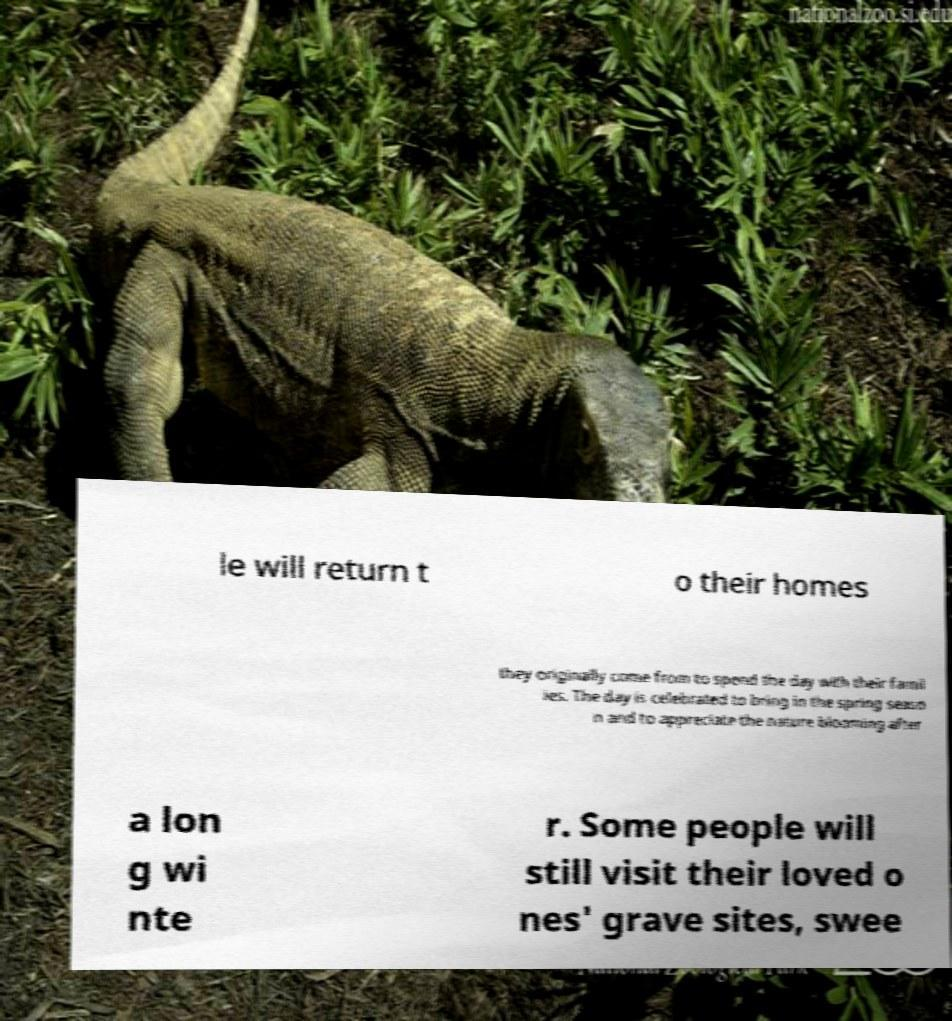Please read and relay the text visible in this image. What does it say? le will return t o their homes they originally come from to spend the day with their famil ies. The day is celebrated to bring in the spring seaso n and to appreciate the nature blooming after a lon g wi nte r. Some people will still visit their loved o nes' grave sites, swee 